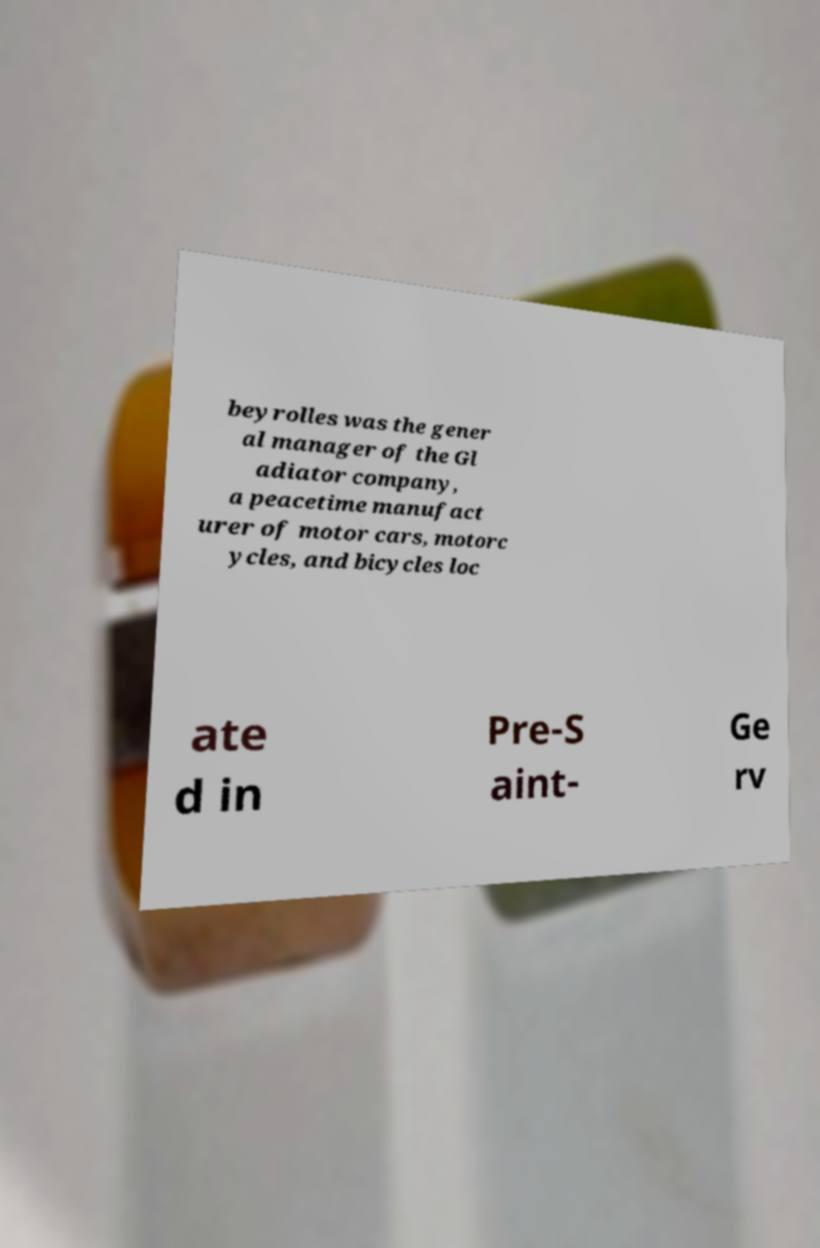Please identify and transcribe the text found in this image. beyrolles was the gener al manager of the Gl adiator company, a peacetime manufact urer of motor cars, motorc ycles, and bicycles loc ate d in Pre-S aint- Ge rv 